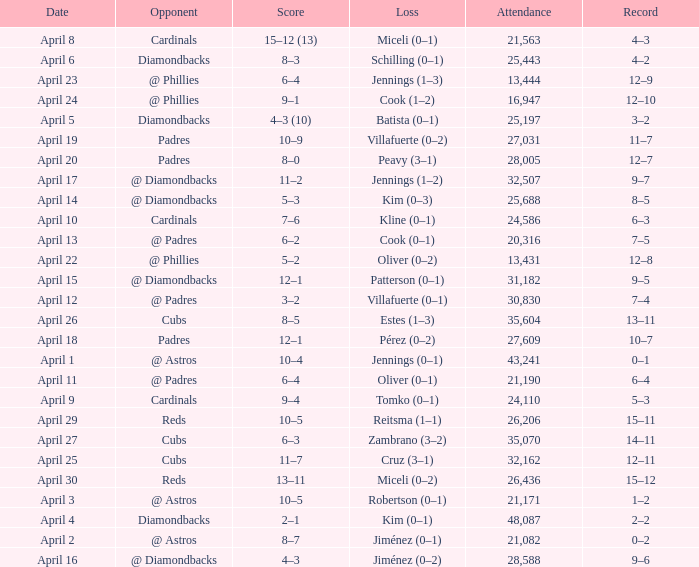What is the team's record on april 23? 12–9. Could you parse the entire table? {'header': ['Date', 'Opponent', 'Score', 'Loss', 'Attendance', 'Record'], 'rows': [['April 8', 'Cardinals', '15–12 (13)', 'Miceli (0–1)', '21,563', '4–3'], ['April 6', 'Diamondbacks', '8–3', 'Schilling (0–1)', '25,443', '4–2'], ['April 23', '@ Phillies', '6–4', 'Jennings (1–3)', '13,444', '12–9'], ['April 24', '@ Phillies', '9–1', 'Cook (1–2)', '16,947', '12–10'], ['April 5', 'Diamondbacks', '4–3 (10)', 'Batista (0–1)', '25,197', '3–2'], ['April 19', 'Padres', '10–9', 'Villafuerte (0–2)', '27,031', '11–7'], ['April 20', 'Padres', '8–0', 'Peavy (3–1)', '28,005', '12–7'], ['April 17', '@ Diamondbacks', '11–2', 'Jennings (1–2)', '32,507', '9–7'], ['April 14', '@ Diamondbacks', '5–3', 'Kim (0–3)', '25,688', '8–5'], ['April 10', 'Cardinals', '7–6', 'Kline (0–1)', '24,586', '6–3'], ['April 13', '@ Padres', '6–2', 'Cook (0–1)', '20,316', '7–5'], ['April 22', '@ Phillies', '5–2', 'Oliver (0–2)', '13,431', '12–8'], ['April 15', '@ Diamondbacks', '12–1', 'Patterson (0–1)', '31,182', '9–5'], ['April 12', '@ Padres', '3–2', 'Villafuerte (0–1)', '30,830', '7–4'], ['April 26', 'Cubs', '8–5', 'Estes (1–3)', '35,604', '13–11'], ['April 18', 'Padres', '12–1', 'Pérez (0–2)', '27,609', '10–7'], ['April 1', '@ Astros', '10–4', 'Jennings (0–1)', '43,241', '0–1'], ['April 11', '@ Padres', '6–4', 'Oliver (0–1)', '21,190', '6–4'], ['April 9', 'Cardinals', '9–4', 'Tomko (0–1)', '24,110', '5–3'], ['April 29', 'Reds', '10–5', 'Reitsma (1–1)', '26,206', '15–11'], ['April 27', 'Cubs', '6–3', 'Zambrano (3–2)', '35,070', '14–11'], ['April 25', 'Cubs', '11–7', 'Cruz (3–1)', '32,162', '12–11'], ['April 30', 'Reds', '13–11', 'Miceli (0–2)', '26,436', '15–12'], ['April 3', '@ Astros', '10–5', 'Robertson (0–1)', '21,171', '1–2'], ['April 4', 'Diamondbacks', '2–1', 'Kim (0–1)', '48,087', '2–2'], ['April 2', '@ Astros', '8–7', 'Jiménez (0–1)', '21,082', '0–2'], ['April 16', '@ Diamondbacks', '4–3', 'Jiménez (0–2)', '28,588', '9–6']]} 